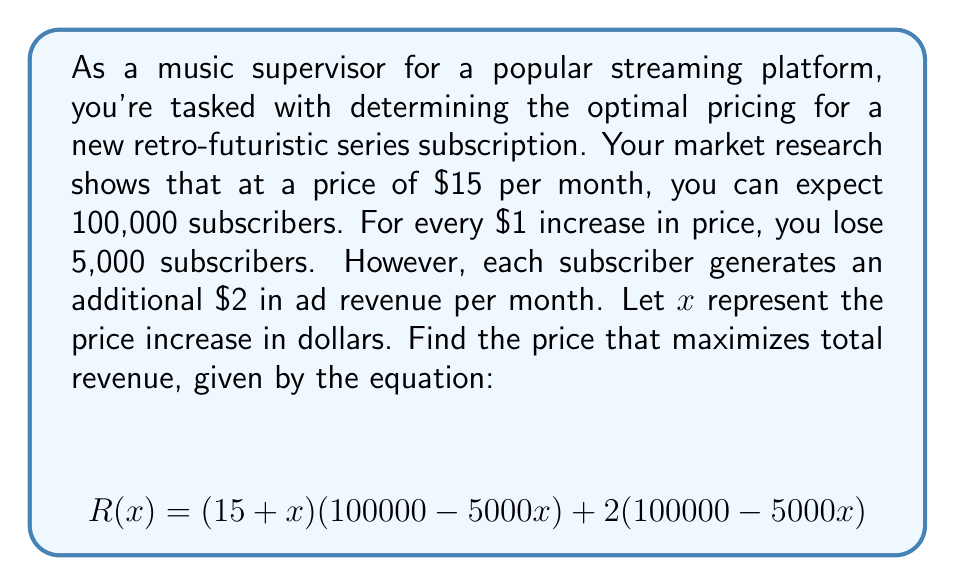Can you solve this math problem? Let's approach this step-by-step:

1) First, let's expand the revenue equation:
   $$R(x) = (15 + x)(100000 - 5000x) + 2(100000 - 5000x)$$
   $$R(x) = 1500000 - 75000x + 100000x - 5000x^2 + 200000 - 10000x$$
   $$R(x) = 1700000 + 15000x - 5000x^2$$

2) To find the maximum revenue, we need to find the vertex of this parabola. We can do this by finding where the derivative equals zero:

   $$R'(x) = 15000 - 10000x$$

3) Set the derivative to zero and solve for x:
   $$15000 - 10000x = 0$$
   $$15000 = 10000x$$
   $$x = 1.5$$

4) This means the revenue is maximized when the price is increased by $1.50.

5) To find the optimal price, we add this to the original price:
   $$15 + 1.5 = 16.5$$

Therefore, the optimal price for the subscription is $16.50 per month.
Answer: $16.50 per month 